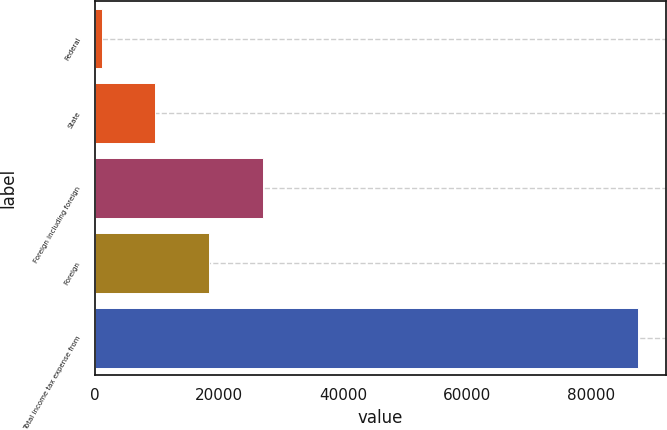Convert chart to OTSL. <chart><loc_0><loc_0><loc_500><loc_500><bar_chart><fcel>Federal<fcel>State<fcel>Foreign including foreign<fcel>Foreign<fcel>Total income tax expense from<nl><fcel>1104<fcel>9761.5<fcel>27076.5<fcel>18419<fcel>87679<nl></chart> 